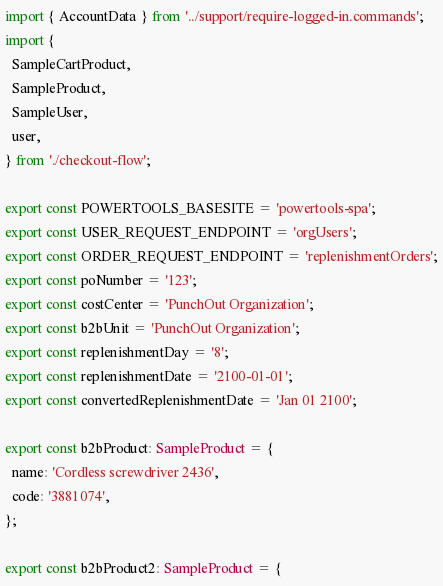<code> <loc_0><loc_0><loc_500><loc_500><_TypeScript_>import { AccountData } from '../support/require-logged-in.commands';
import {
  SampleCartProduct,
  SampleProduct,
  SampleUser,
  user,
} from './checkout-flow';

export const POWERTOOLS_BASESITE = 'powertools-spa';
export const USER_REQUEST_ENDPOINT = 'orgUsers';
export const ORDER_REQUEST_ENDPOINT = 'replenishmentOrders';
export const poNumber = '123';
export const costCenter = 'PunchOut Organization';
export const b2bUnit = 'PunchOut Organization';
export const replenishmentDay = '8';
export const replenishmentDate = '2100-01-01';
export const convertedReplenishmentDate = 'Jan 01 2100';

export const b2bProduct: SampleProduct = {
  name: 'Cordless screwdriver 2436',
  code: '3881074',
};

export const b2bProduct2: SampleProduct = {</code> 